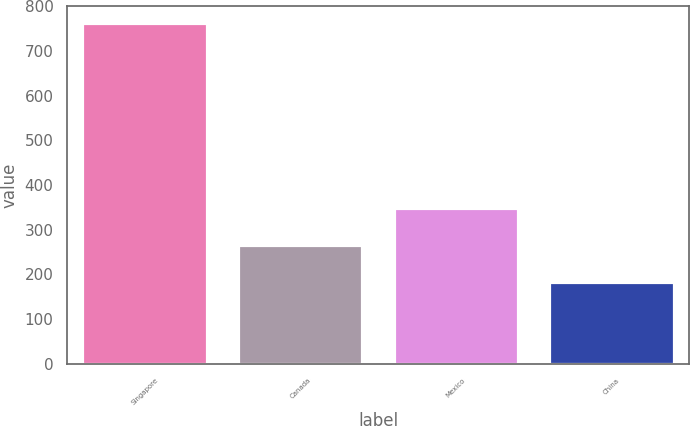Convert chart to OTSL. <chart><loc_0><loc_0><loc_500><loc_500><bar_chart><fcel>Singapore<fcel>Canada<fcel>Mexico<fcel>China<nl><fcel>762<fcel>266<fcel>349<fcel>182<nl></chart> 